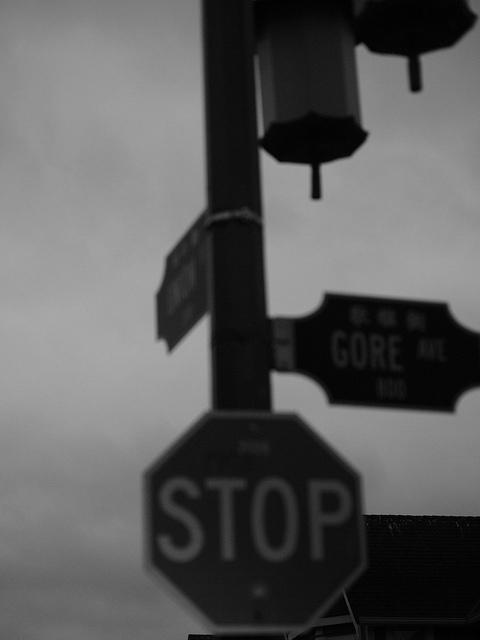Yes, this is the back?
Concise answer only. No. What is on top of the sign?
Quick response, please. Light. Are there clouds in the sky?
Quick response, please. Yes. Is this the back of the sign?
Quick response, please. No. Is the street sign for Gore above or below the stop sign?
Keep it brief. Above. 